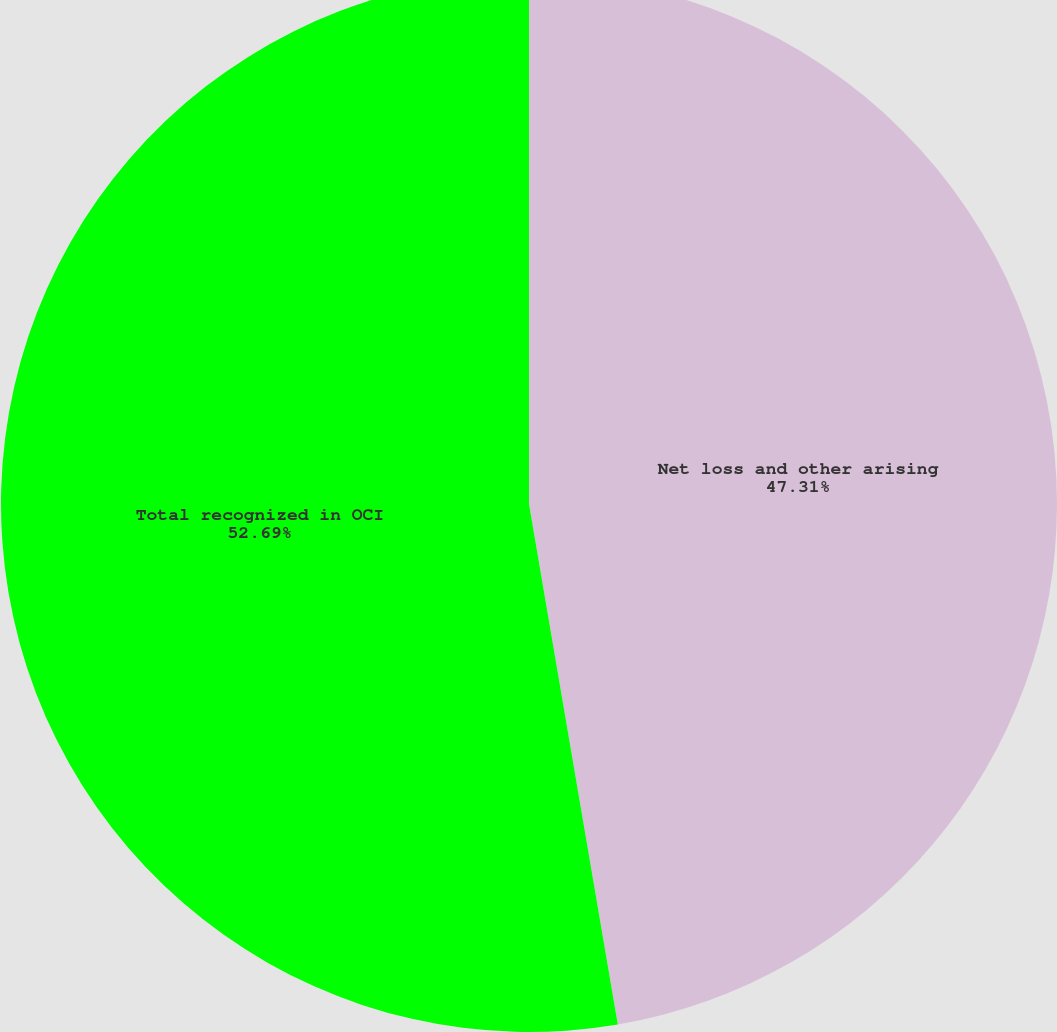Convert chart to OTSL. <chart><loc_0><loc_0><loc_500><loc_500><pie_chart><fcel>Net loss and other arising<fcel>Total recognized in OCI<nl><fcel>47.31%<fcel>52.69%<nl></chart> 